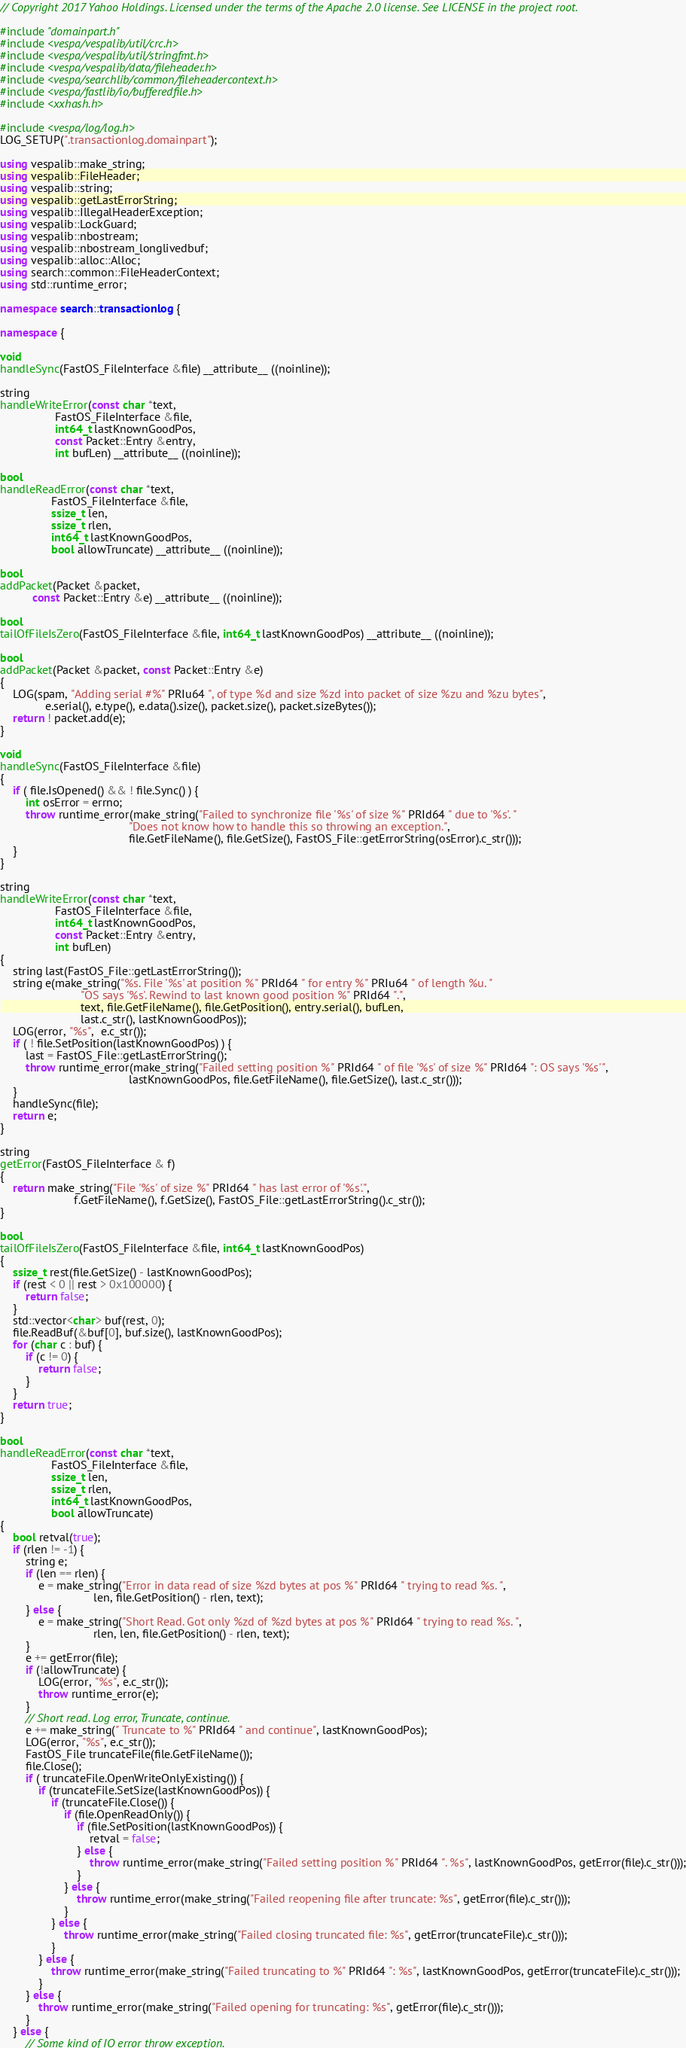Convert code to text. <code><loc_0><loc_0><loc_500><loc_500><_C++_>// Copyright 2017 Yahoo Holdings. Licensed under the terms of the Apache 2.0 license. See LICENSE in the project root.

#include "domainpart.h"
#include <vespa/vespalib/util/crc.h>
#include <vespa/vespalib/util/stringfmt.h>
#include <vespa/vespalib/data/fileheader.h>
#include <vespa/searchlib/common/fileheadercontext.h>
#include <vespa/fastlib/io/bufferedfile.h>
#include <xxhash.h>

#include <vespa/log/log.h>
LOG_SETUP(".transactionlog.domainpart");

using vespalib::make_string;
using vespalib::FileHeader;
using vespalib::string;
using vespalib::getLastErrorString;
using vespalib::IllegalHeaderException;
using vespalib::LockGuard;
using vespalib::nbostream;
using vespalib::nbostream_longlivedbuf;
using vespalib::alloc::Alloc;
using search::common::FileHeaderContext;
using std::runtime_error;

namespace search::transactionlog {

namespace {

void
handleSync(FastOS_FileInterface &file) __attribute__ ((noinline));

string
handleWriteError(const char *text,
                 FastOS_FileInterface &file,
                 int64_t lastKnownGoodPos,
                 const Packet::Entry &entry,
                 int bufLen) __attribute__ ((noinline));

bool
handleReadError(const char *text,
                FastOS_FileInterface &file,
                ssize_t len,
                ssize_t rlen,
                int64_t lastKnownGoodPos,
                bool allowTruncate) __attribute__ ((noinline));

bool
addPacket(Packet &packet,
          const Packet::Entry &e) __attribute__ ((noinline));

bool
tailOfFileIsZero(FastOS_FileInterface &file, int64_t lastKnownGoodPos) __attribute__ ((noinline));

bool
addPacket(Packet &packet, const Packet::Entry &e)
{
    LOG(spam, "Adding serial #%" PRIu64 ", of type %d and size %zd into packet of size %zu and %zu bytes",
              e.serial(), e.type(), e.data().size(), packet.size(), packet.sizeBytes());
    return ! packet.add(e);
}

void
handleSync(FastOS_FileInterface &file)
{
    if ( file.IsOpened() && ! file.Sync() ) {
        int osError = errno;
        throw runtime_error(make_string("Failed to synchronize file '%s' of size %" PRId64 " due to '%s'. "
                                        "Does not know how to handle this so throwing an exception.",
                                        file.GetFileName(), file.GetSize(), FastOS_File::getErrorString(osError).c_str()));
    }
}

string
handleWriteError(const char *text,
                 FastOS_FileInterface &file,
                 int64_t lastKnownGoodPos,
                 const Packet::Entry &entry,
                 int bufLen)
{
    string last(FastOS_File::getLastErrorString());
    string e(make_string("%s. File '%s' at position %" PRId64 " for entry %" PRIu64 " of length %u. "
                         "OS says '%s'. Rewind to last known good position %" PRId64 ".",
                         text, file.GetFileName(), file.GetPosition(), entry.serial(), bufLen,
                         last.c_str(), lastKnownGoodPos));
    LOG(error, "%s",  e.c_str());
    if ( ! file.SetPosition(lastKnownGoodPos) ) {
        last = FastOS_File::getLastErrorString();
        throw runtime_error(make_string("Failed setting position %" PRId64 " of file '%s' of size %" PRId64 ": OS says '%s'",
                                        lastKnownGoodPos, file.GetFileName(), file.GetSize(), last.c_str()));
    }
    handleSync(file);
    return e;
}

string
getError(FastOS_FileInterface & f)
{
    return make_string("File '%s' of size %" PRId64 " has last error of '%s'.",
                       f.GetFileName(), f.GetSize(), FastOS_File::getLastErrorString().c_str());
}

bool
tailOfFileIsZero(FastOS_FileInterface &file, int64_t lastKnownGoodPos)
{
    ssize_t rest(file.GetSize() - lastKnownGoodPos);
    if (rest < 0 || rest > 0x100000) {
        return false;
    }
    std::vector<char> buf(rest, 0);
    file.ReadBuf(&buf[0], buf.size(), lastKnownGoodPos);
    for (char c : buf) {
        if (c != 0) {
            return false;
        }
    }
    return true;
}

bool
handleReadError(const char *text,
                FastOS_FileInterface &file,
                ssize_t len,
                ssize_t rlen,
                int64_t lastKnownGoodPos,
                bool allowTruncate)
{
    bool retval(true);
    if (rlen != -1) {
        string e;
        if (len == rlen) {
            e = make_string("Error in data read of size %zd bytes at pos %" PRId64 " trying to read %s. ",
                             len, file.GetPosition() - rlen, text);
        } else {
            e = make_string("Short Read. Got only %zd of %zd bytes at pos %" PRId64 " trying to read %s. ",
                             rlen, len, file.GetPosition() - rlen, text);
        }
        e += getError(file);
        if (!allowTruncate) {
            LOG(error, "%s", e.c_str());
            throw runtime_error(e);
        }
        // Short read. Log error, Truncate, continue.
        e += make_string(" Truncate to %" PRId64 " and continue", lastKnownGoodPos);
        LOG(error, "%s", e.c_str());
        FastOS_File truncateFile(file.GetFileName());
        file.Close();
        if ( truncateFile.OpenWriteOnlyExisting()) {
            if (truncateFile.SetSize(lastKnownGoodPos)) {
                if (truncateFile.Close()) {
                    if (file.OpenReadOnly()) {
                        if (file.SetPosition(lastKnownGoodPos)) {
                            retval = false;
                        } else {
                            throw runtime_error(make_string("Failed setting position %" PRId64 ". %s", lastKnownGoodPos, getError(file).c_str()));
                        }
                    } else {
                        throw runtime_error(make_string("Failed reopening file after truncate: %s", getError(file).c_str()));
                    }
                } else {
                    throw runtime_error(make_string("Failed closing truncated file: %s", getError(truncateFile).c_str()));
                }
            } else {
                throw runtime_error(make_string("Failed truncating to %" PRId64 ": %s", lastKnownGoodPos, getError(truncateFile).c_str()));
            }
        } else {
            throw runtime_error(make_string("Failed opening for truncating: %s", getError(file).c_str()));
        }
    } else {
        // Some kind of IO error throw exception.</code> 